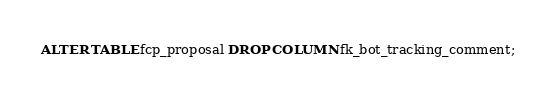<code> <loc_0><loc_0><loc_500><loc_500><_SQL_>ALTER TABLE fcp_proposal DROP COLUMN fk_bot_tracking_comment;
</code> 